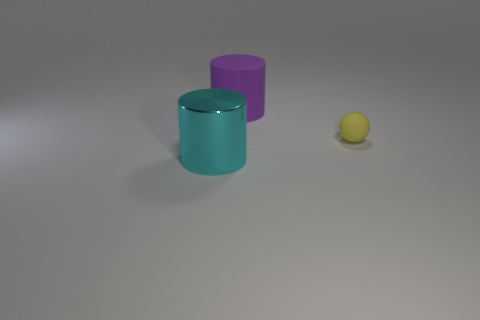How many objects are tiny objects or metallic cylinders?
Provide a succinct answer. 2. The object that is both behind the metal cylinder and to the left of the small yellow object has what shape?
Your answer should be compact. Cylinder. Does the thing that is behind the yellow object have the same material as the tiny sphere?
Keep it short and to the point. Yes. How many objects are either red cubes or objects that are right of the big cyan thing?
Provide a short and direct response. 2. The large object that is the same material as the tiny yellow sphere is what color?
Your answer should be compact. Purple. How many yellow spheres are made of the same material as the big cyan cylinder?
Make the answer very short. 0. What number of balls are there?
Provide a short and direct response. 1. There is a rubber thing that is in front of the purple rubber thing; does it have the same color as the large cylinder on the right side of the cyan object?
Keep it short and to the point. No. There is a purple cylinder; how many yellow rubber things are in front of it?
Ensure brevity in your answer.  1. Is there a big red rubber object that has the same shape as the small matte thing?
Ensure brevity in your answer.  No. 